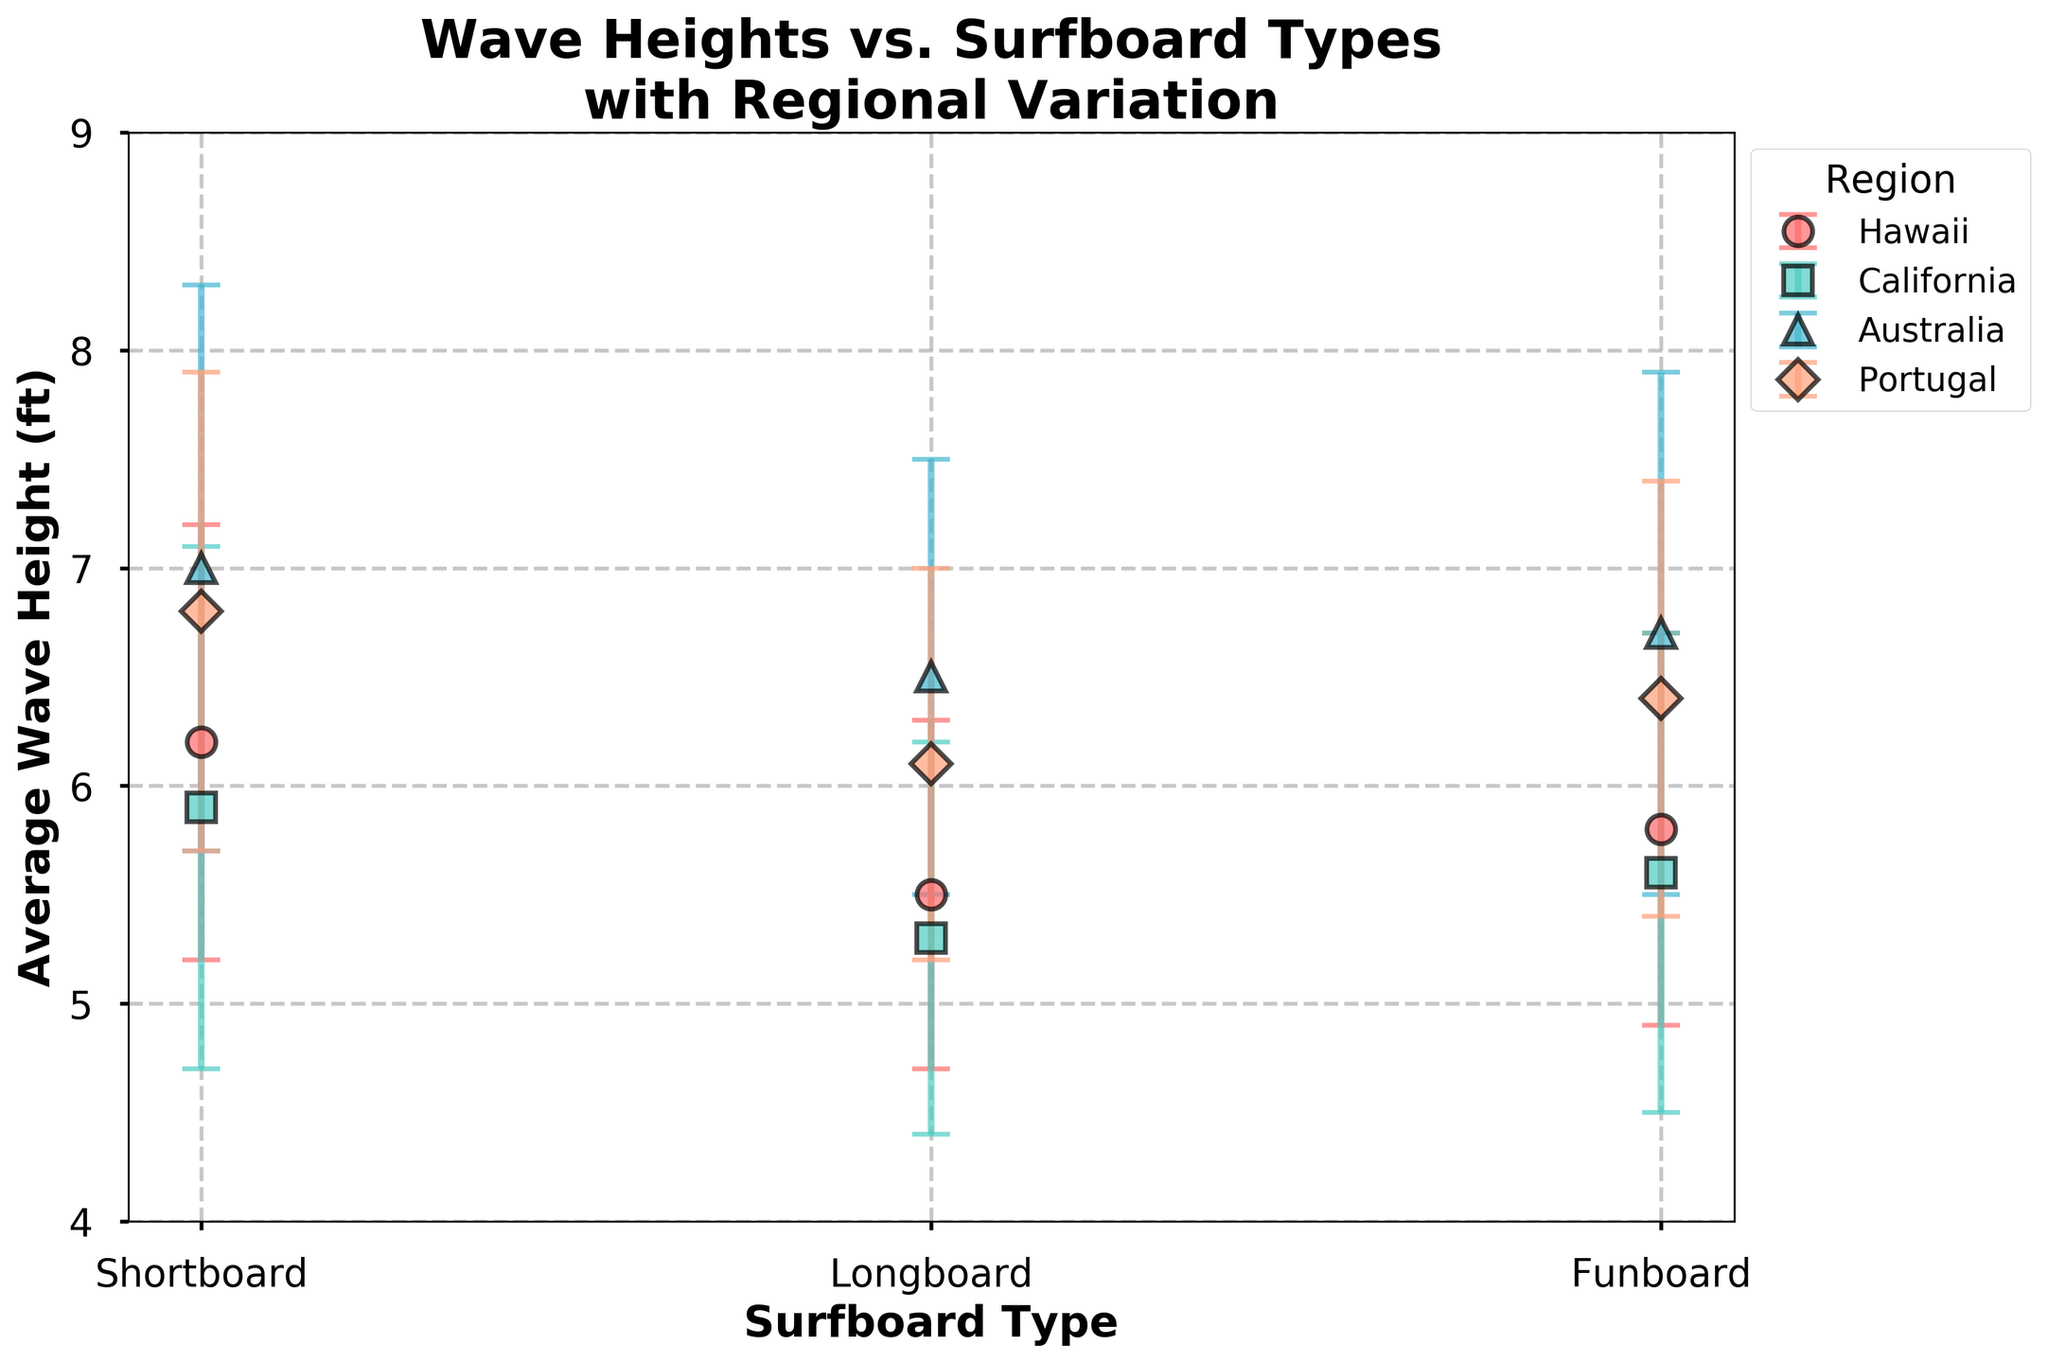What is the title of the figure? The title is written at the top of the figure in larger, bold font and it summarizes the main elements being visualized in the plot.
Answer: Wave Heights vs. Surfboard Types with Regional Variation Which surfboard type has the highest average wave height in California? By looking at the point corresponding to California in the plot for each surfboard type, the highest average wave height can be observed for Shortboard.
Answer: Shortboard How does the average wave height for Longboards in Australia compare to those in Hawaii? Look at the points for Longboards in both Australia and Hawaii. The average wave height for Longboards in Australia is higher than in Hawaii.
Answer: Higher in Australia Which region has the largest error bars for Shortboards? Observe the length of error bars for Shortboards across all regions. The region with the longest error bars indicates the largest standard deviation. California has the largest error bars for Shortboards.
Answer: California What is the average wave height across all surfboard types in Portugal? Calculate the average of the average wave heights for Shortboard, Longboard, and Funboard in Portugal: (6.8 + 6.1 + 6.4)/3.
Answer: 6.43 ft Which surfboard type in Hawaii shows the smallest standard deviation? Look at the error bars for all surfboard types in Hawaii. The surfboard type with the shortest error bars has the smallest standard deviation. Longboard has the smallest standard deviation in Hawaii.
Answer: Longboard Between California and Australia, which region shows a higher average wave height for Funboards? Compare the average wave heights for Funboards in both regions. Australia's Funboards have a higher average wave height.
Answer: Australia If you were to rank the regions by the average wave height for Shortboards, what would the order be from highest to lowest? Examine the average wave heights for Shortboards in each region and rank them: Australia (7.0), Portugal (6.8), Hawaii (6.2), California (5.9).
Answer: Australia > Portugal > Hawaii > California What is the range of average wave heights for Longboards across all regions? Find the minimum and maximum average wave heights for Longboards: 5.3 ft (California) and 6.5 ft (Australia), respectively. The range is 6.5 - 5.3 = 1.2 ft.
Answer: 1.2 ft 